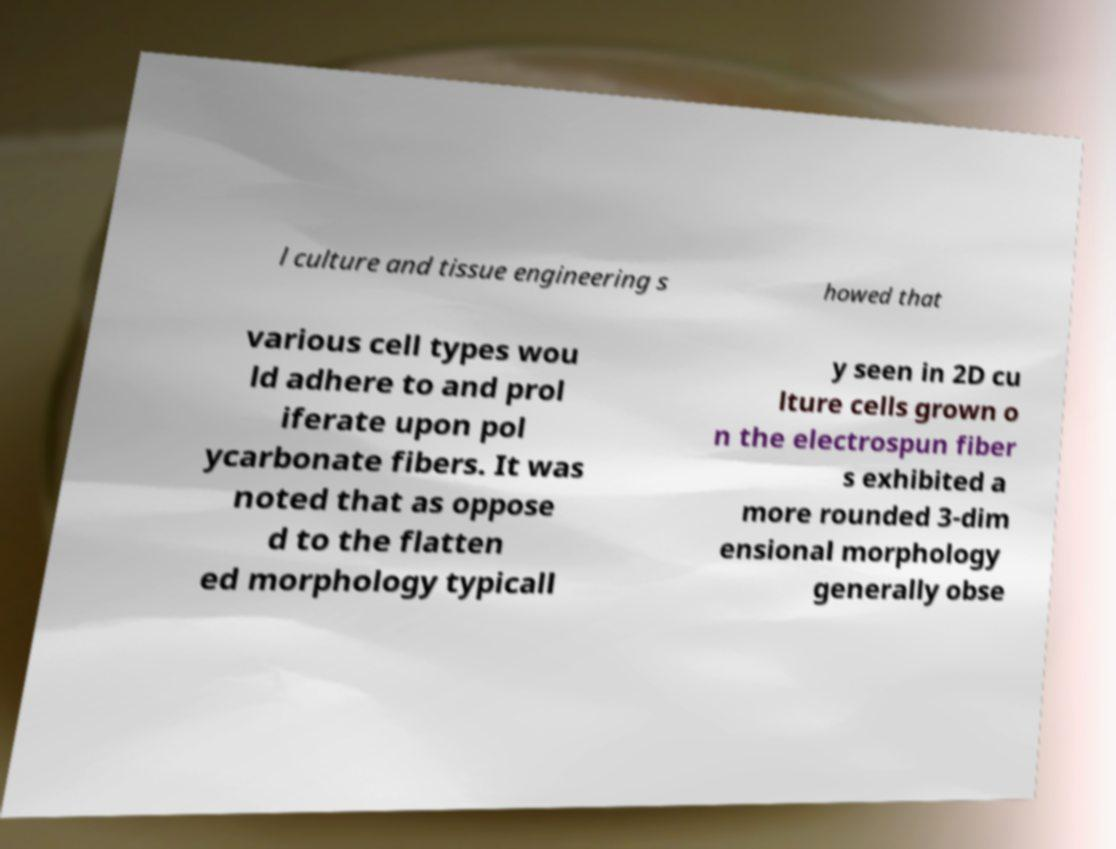There's text embedded in this image that I need extracted. Can you transcribe it verbatim? l culture and tissue engineering s howed that various cell types wou ld adhere to and prol iferate upon pol ycarbonate fibers. It was noted that as oppose d to the flatten ed morphology typicall y seen in 2D cu lture cells grown o n the electrospun fiber s exhibited a more rounded 3-dim ensional morphology generally obse 